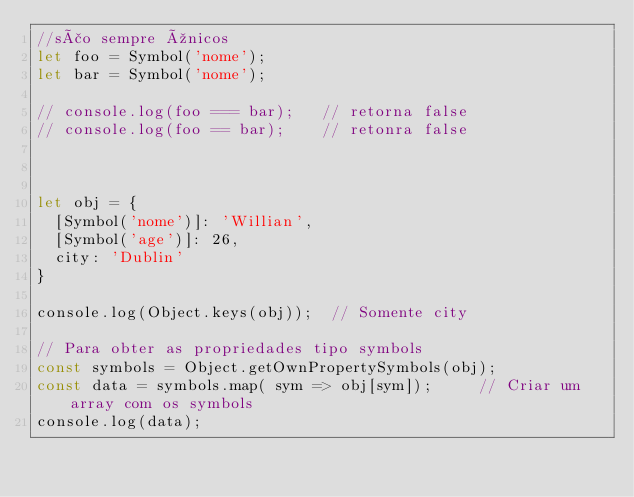Convert code to text. <code><loc_0><loc_0><loc_500><loc_500><_JavaScript_>//são sempre únicos
let foo = Symbol('nome');
let bar = Symbol('nome');

// console.log(foo === bar);   // retorna false
// console.log(foo == bar);    // retonra false



let obj = {
  [Symbol('nome')]: 'Willian',
  [Symbol('age')]: 26,
  city: 'Dublin'
}

console.log(Object.keys(obj));  // Somente city

// Para obter as propriedades tipo symbols
const symbols = Object.getOwnPropertySymbols(obj);
const data = symbols.map( sym => obj[sym]);     // Criar um array com os symbols
console.log(data);
</code> 